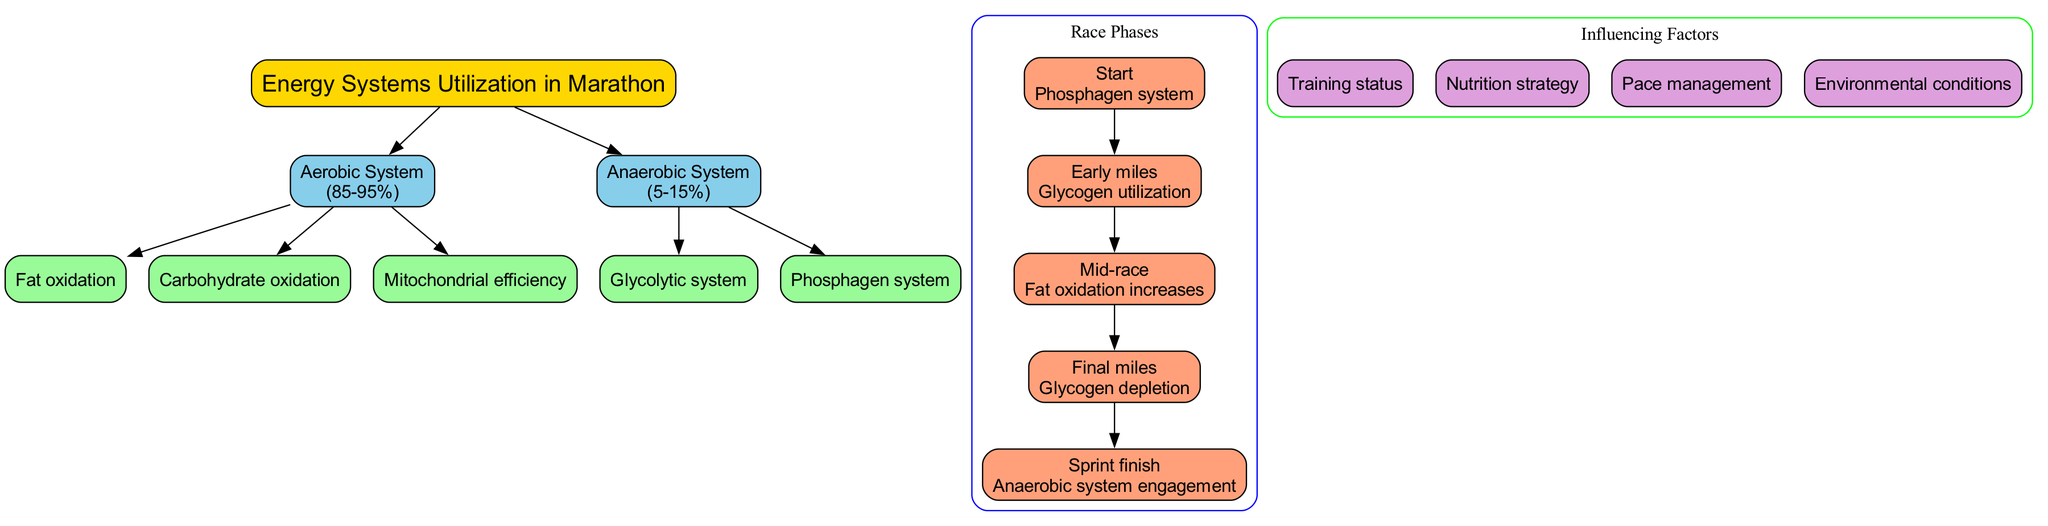What is the central topic of the diagram? The diagram clearly labels the central node as "Energy Systems Utilization in Marathon," which states the primary focus of the diagram.
Answer: Energy Systems Utilization in Marathon What percentage of energy utilization belongs to the Aerobic System? The diagram indicates that the Aerobic System comprises a range from "85-95%" by showing this information inside the node associated with the Aerobic System.
Answer: 85-95% List one sub-element of the Anaerobic System. Reviewing the sub-elements linked to the Anaerobic System node, "Glycolytic system" is one of the sub-elements listed there.
Answer: Glycolytic system What energy focus is indicated for the Mid-race phase? The phase labeled "Mid-race" explicitly shows its energy focus as "Fat oxidation increases," which is clear within the corresponding node for this race phase.
Answer: Fat oxidation increases How many total race phases are represented in the diagram? Counting the nodes within the "Race Phases" subgraph indicates there are five distinct phases, which can be counted directly from the diagram.
Answer: 5 Which energy system is predominantly used during the Final miles? The energy focus for the "Final miles" phase is labeled as "Glycogen depletion," which signifies the system primarily engaged during this phase.
Answer: Glycogen depletion What is an influencing factor listed in the diagram? Scanning the "Influencing Factors" section reveals several items, one of which is "Nutrition strategy," as shown in the respective factor node.
Answer: Nutrition strategy Which system is emphasized during the Start phase? The diagram specifies that the energy focus during the "Start" phase is the "Phosphagen system," indicating the system emphasized at the beginning of the race.
Answer: Phosphagen system Explain the energy focus transition from the Early miles to the Mid-race phase. The Early miles are focused on "Glycogen utilization," while the Mid-race phase transitions to "Fat oxidation increases.” This transition emphasizes a shift from carbohydrate utilization to increased reliance on fat as a fuel source.
Answer: Transition from Glycogen utilization to Fat oxidation increases 